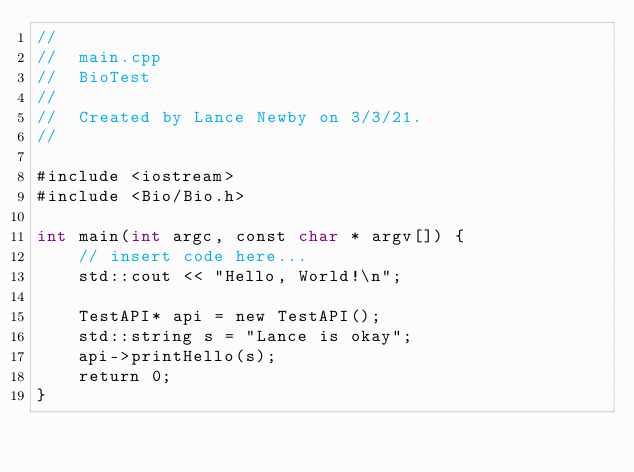Convert code to text. <code><loc_0><loc_0><loc_500><loc_500><_ObjectiveC_>//
//  main.cpp
//  BioTest
//
//  Created by Lance Newby on 3/3/21.
//

#include <iostream>
#include <Bio/Bio.h>

int main(int argc, const char * argv[]) {
    // insert code here...
    std::cout << "Hello, World!\n";

    TestAPI* api = new TestAPI();
    std::string s = "Lance is okay";
    api->printHello(s);
    return 0;
}
</code> 